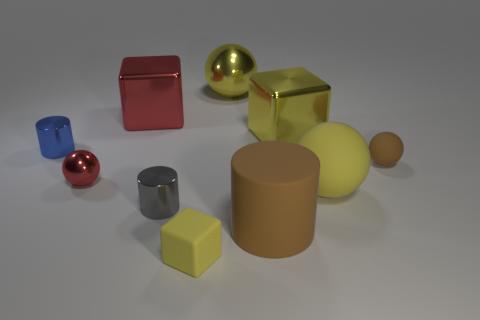Is there a yellow thing that is in front of the tiny object that is behind the small brown rubber thing?
Your response must be concise. Yes. What number of other objects are the same shape as the blue thing?
Give a very brief answer. 2. Is the tiny brown thing the same shape as the big yellow rubber object?
Provide a short and direct response. Yes. What is the color of the cube that is both behind the small rubber ball and to the right of the large red metallic cube?
Your response must be concise. Yellow. There is a matte ball that is the same color as the big metal ball; what size is it?
Provide a short and direct response. Large. How many large things are either gray metal cylinders or purple rubber cylinders?
Offer a very short reply. 0. Is there anything else that is the same color as the big matte cylinder?
Your answer should be very brief. Yes. What is the red thing that is behind the red metallic ball to the left of the large yellow sphere that is to the right of the large metallic ball made of?
Give a very brief answer. Metal. How many matte objects are either big yellow cylinders or red cubes?
Give a very brief answer. 0. What number of gray objects are either big shiny objects or small cylinders?
Your response must be concise. 1. 